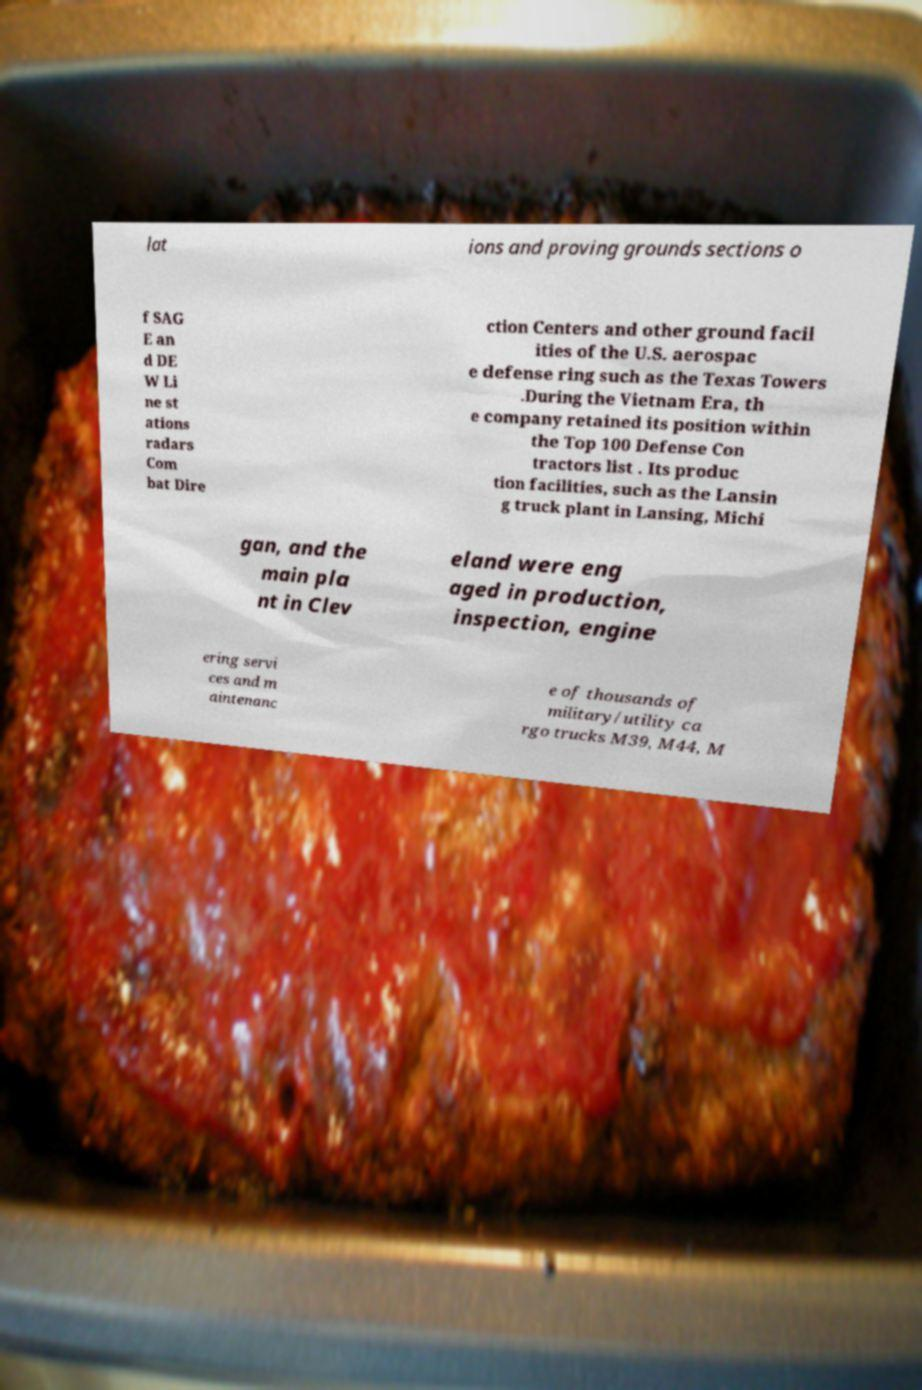Please read and relay the text visible in this image. What does it say? lat ions and proving grounds sections o f SAG E an d DE W Li ne st ations radars Com bat Dire ction Centers and other ground facil ities of the U.S. aerospac e defense ring such as the Texas Towers .During the Vietnam Era, th e company retained its position within the Top 100 Defense Con tractors list . Its produc tion facilities, such as the Lansin g truck plant in Lansing, Michi gan, and the main pla nt in Clev eland were eng aged in production, inspection, engine ering servi ces and m aintenanc e of thousands of military/utility ca rgo trucks M39, M44, M 